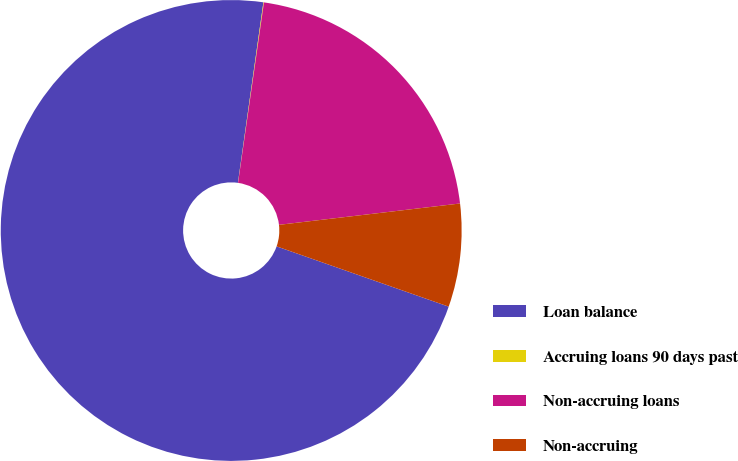Convert chart. <chart><loc_0><loc_0><loc_500><loc_500><pie_chart><fcel>Loan balance<fcel>Accruing loans 90 days past<fcel>Non-accruing loans<fcel>Non-accruing<nl><fcel>71.87%<fcel>0.04%<fcel>20.86%<fcel>7.23%<nl></chart> 